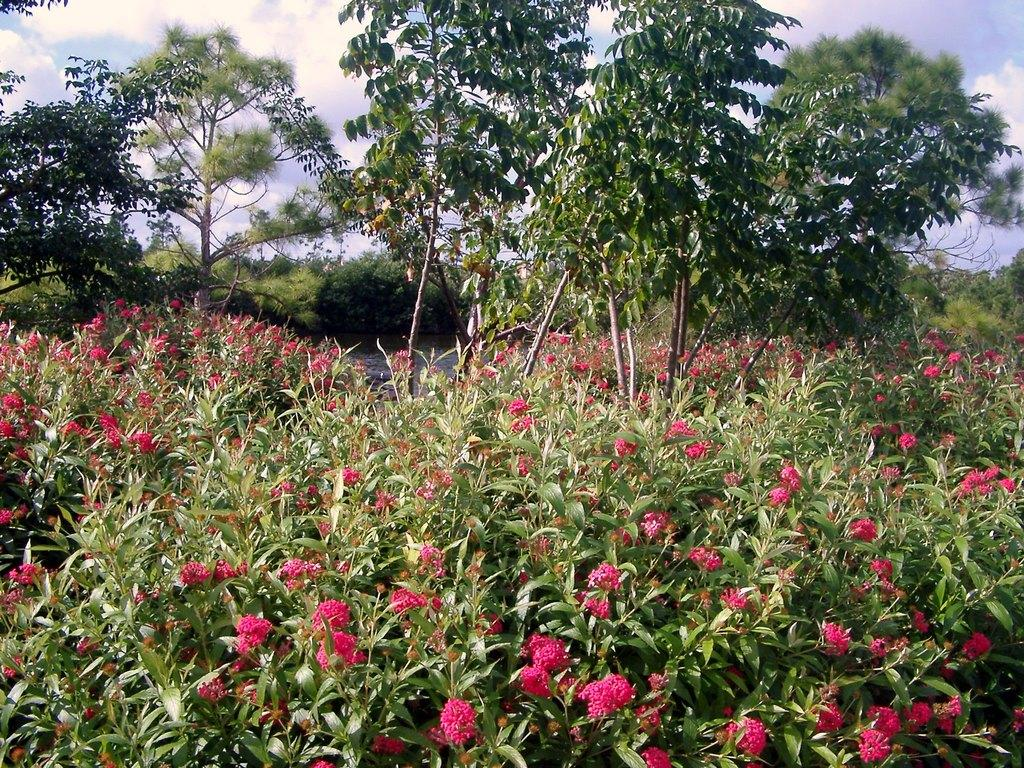What type of vegetation can be seen in the image? There are plants and trees in the image. What is visible at the top of the image? The sky is visible at the top of the image. What type of lunch is being served in the image? There is no lunch present in the image; it features plants, trees, and the sky. How many cats can be seen playing with the plants in the image? There are no cats present in the image; it only features plants, trees, and the sky. 